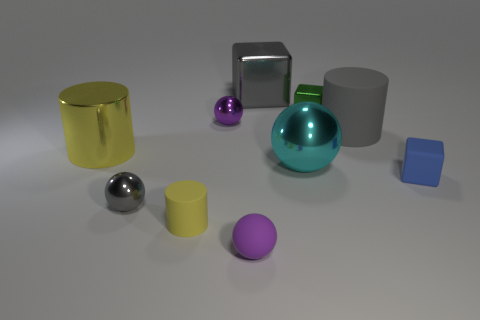There is a green shiny thing; does it have the same shape as the purple object that is behind the large yellow cylinder? The green object appears to be a sphere with a reflective surface, whereas the purple object, partly obscured by the yellow cylinder, seems to be more egg-shaped. So, they do not share the same shape. 